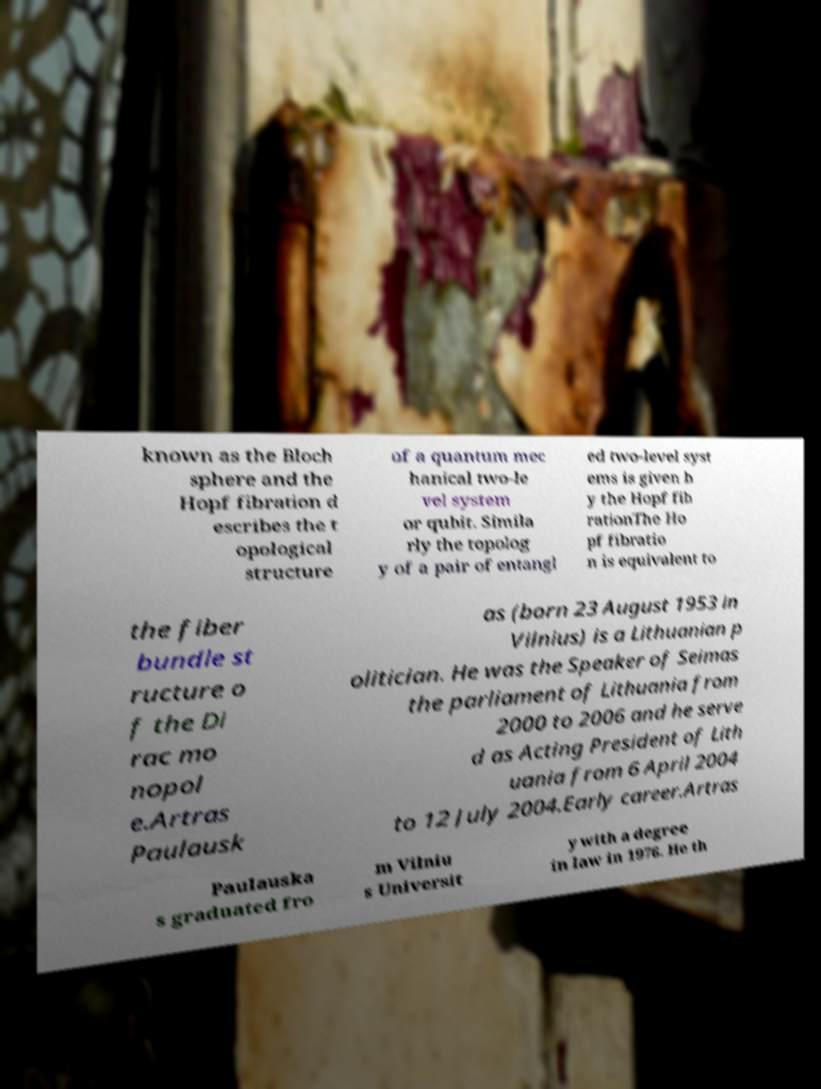I need the written content from this picture converted into text. Can you do that? known as the Bloch sphere and the Hopf fibration d escribes the t opological structure of a quantum mec hanical two-le vel system or qubit. Simila rly the topolog y of a pair of entangl ed two-level syst ems is given b y the Hopf fib rationThe Ho pf fibratio n is equivalent to the fiber bundle st ructure o f the Di rac mo nopol e.Artras Paulausk as (born 23 August 1953 in Vilnius) is a Lithuanian p olitician. He was the Speaker of Seimas the parliament of Lithuania from 2000 to 2006 and he serve d as Acting President of Lith uania from 6 April 2004 to 12 July 2004.Early career.Artras Paulauska s graduated fro m Vilniu s Universit y with a degree in law in 1976. He th 